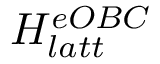<formula> <loc_0><loc_0><loc_500><loc_500>H _ { l a t t } ^ { e O B C }</formula> 